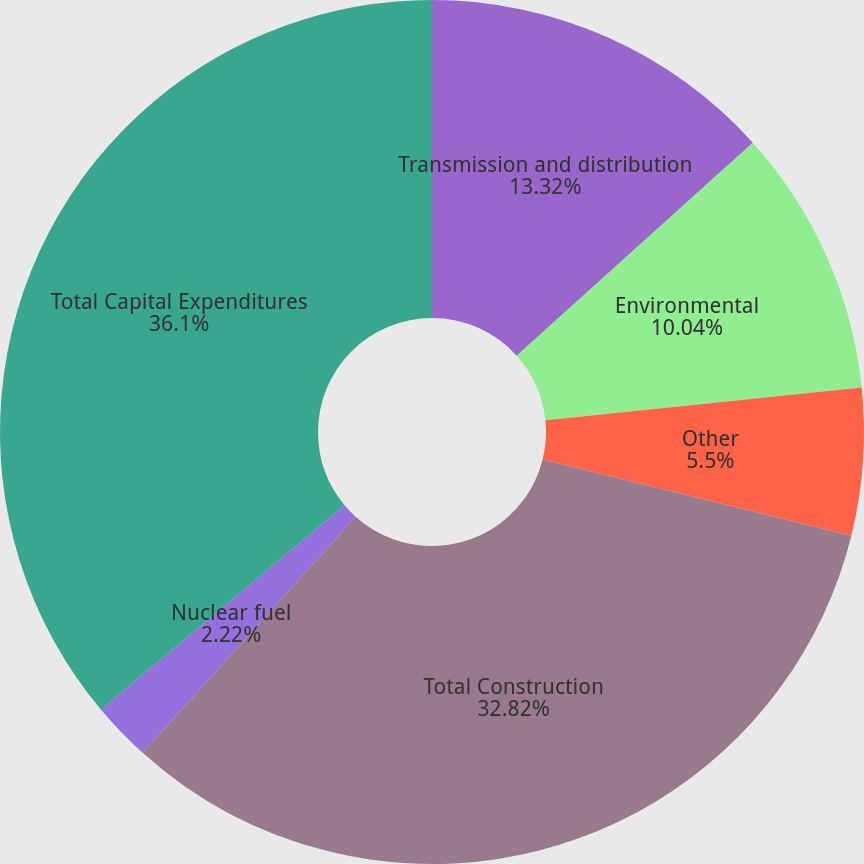Convert chart. <chart><loc_0><loc_0><loc_500><loc_500><pie_chart><fcel>Transmission and distribution<fcel>Environmental<fcel>Other<fcel>Total Construction<fcel>Nuclear fuel<fcel>Total Capital Expenditures<nl><fcel>13.32%<fcel>10.04%<fcel>5.5%<fcel>32.82%<fcel>2.22%<fcel>36.1%<nl></chart> 